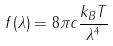Convert formula to latex. <formula><loc_0><loc_0><loc_500><loc_500>f ( \lambda ) = 8 \pi c { \frac { k _ { B } T } { \lambda ^ { 4 } } }</formula> 